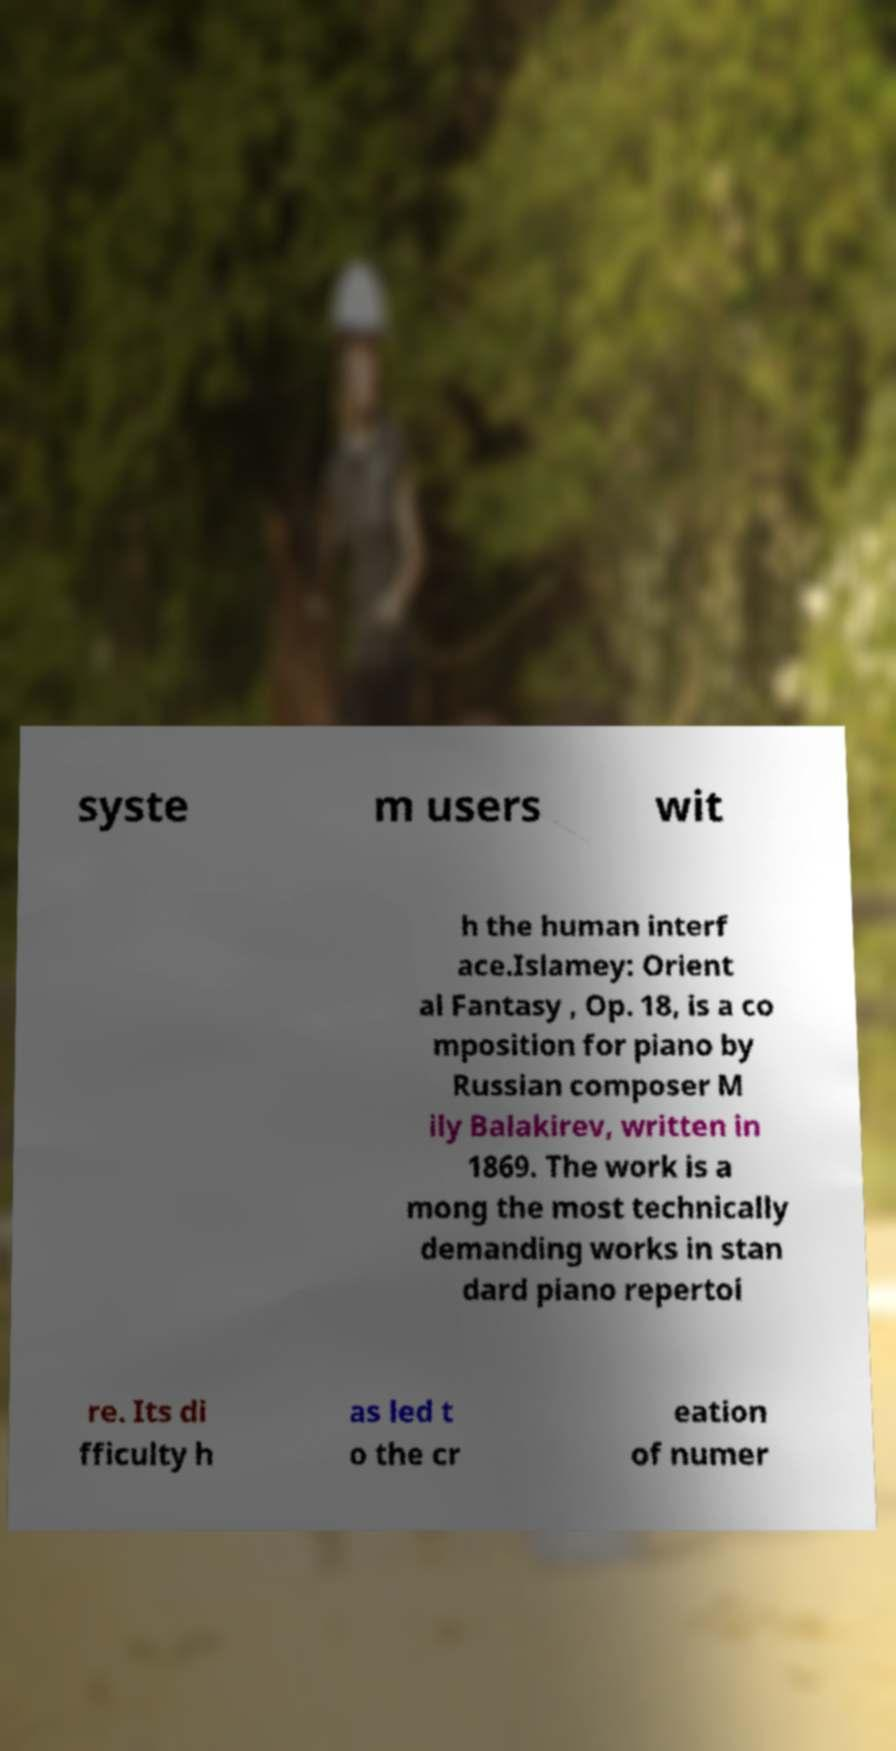Please identify and transcribe the text found in this image. syste m users wit h the human interf ace.Islamey: Orient al Fantasy , Op. 18, is a co mposition for piano by Russian composer M ily Balakirev, written in 1869. The work is a mong the most technically demanding works in stan dard piano repertoi re. Its di fficulty h as led t o the cr eation of numer 